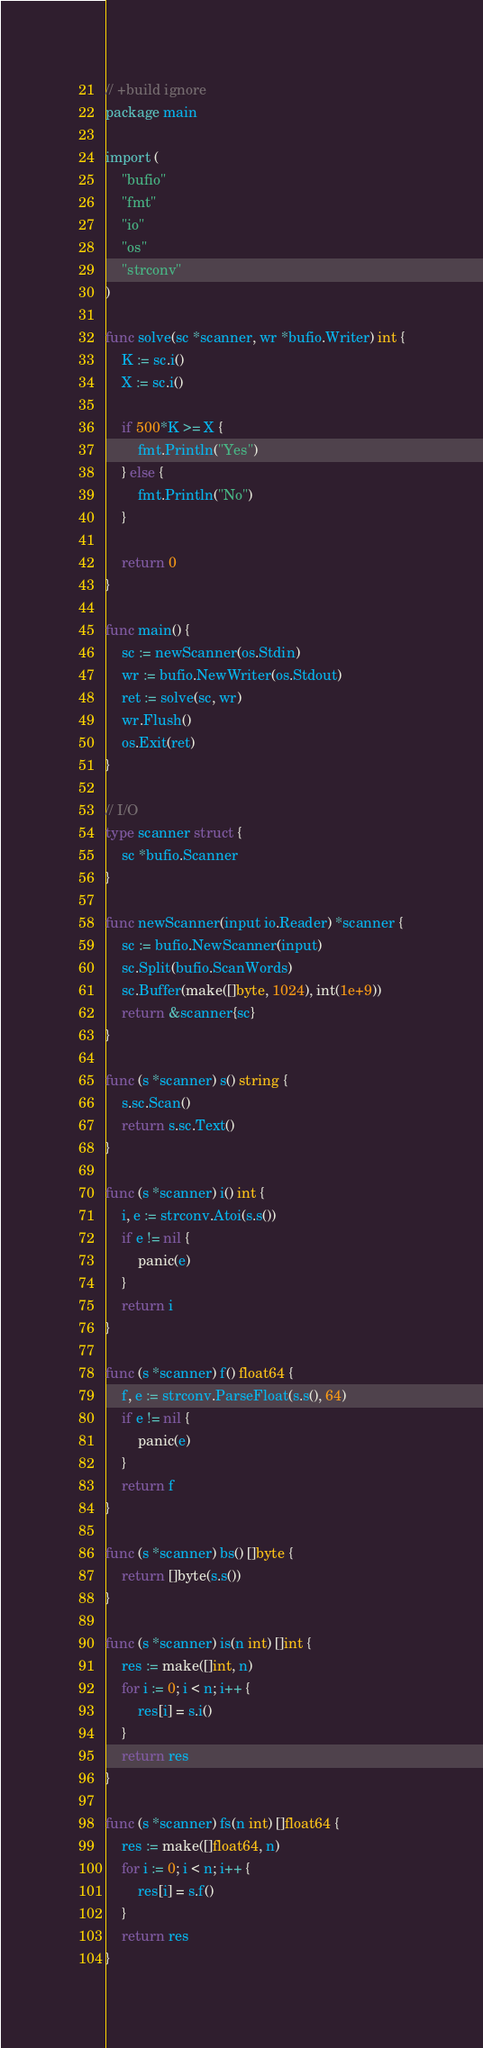Convert code to text. <code><loc_0><loc_0><loc_500><loc_500><_Go_>// +build ignore
package main

import (
	"bufio"
	"fmt"
	"io"
	"os"
	"strconv"
)

func solve(sc *scanner, wr *bufio.Writer) int {
	K := sc.i()
	X := sc.i()

	if 500*K >= X {
		fmt.Println("Yes")
	} else {
		fmt.Println("No")
	}

	return 0
}

func main() {
	sc := newScanner(os.Stdin)
	wr := bufio.NewWriter(os.Stdout)
	ret := solve(sc, wr)
	wr.Flush()
	os.Exit(ret)
}

// I/O
type scanner struct {
	sc *bufio.Scanner
}

func newScanner(input io.Reader) *scanner {
	sc := bufio.NewScanner(input)
	sc.Split(bufio.ScanWords)
	sc.Buffer(make([]byte, 1024), int(1e+9))
	return &scanner{sc}
}

func (s *scanner) s() string {
	s.sc.Scan()
	return s.sc.Text()
}

func (s *scanner) i() int {
	i, e := strconv.Atoi(s.s())
	if e != nil {
		panic(e)
	}
	return i
}

func (s *scanner) f() float64 {
	f, e := strconv.ParseFloat(s.s(), 64)
	if e != nil {
		panic(e)
	}
	return f
}

func (s *scanner) bs() []byte {
	return []byte(s.s())
}

func (s *scanner) is(n int) []int {
	res := make([]int, n)
	for i := 0; i < n; i++ {
		res[i] = s.i()
	}
	return res
}

func (s *scanner) fs(n int) []float64 {
	res := make([]float64, n)
	for i := 0; i < n; i++ {
		res[i] = s.f()
	}
	return res
}
</code> 